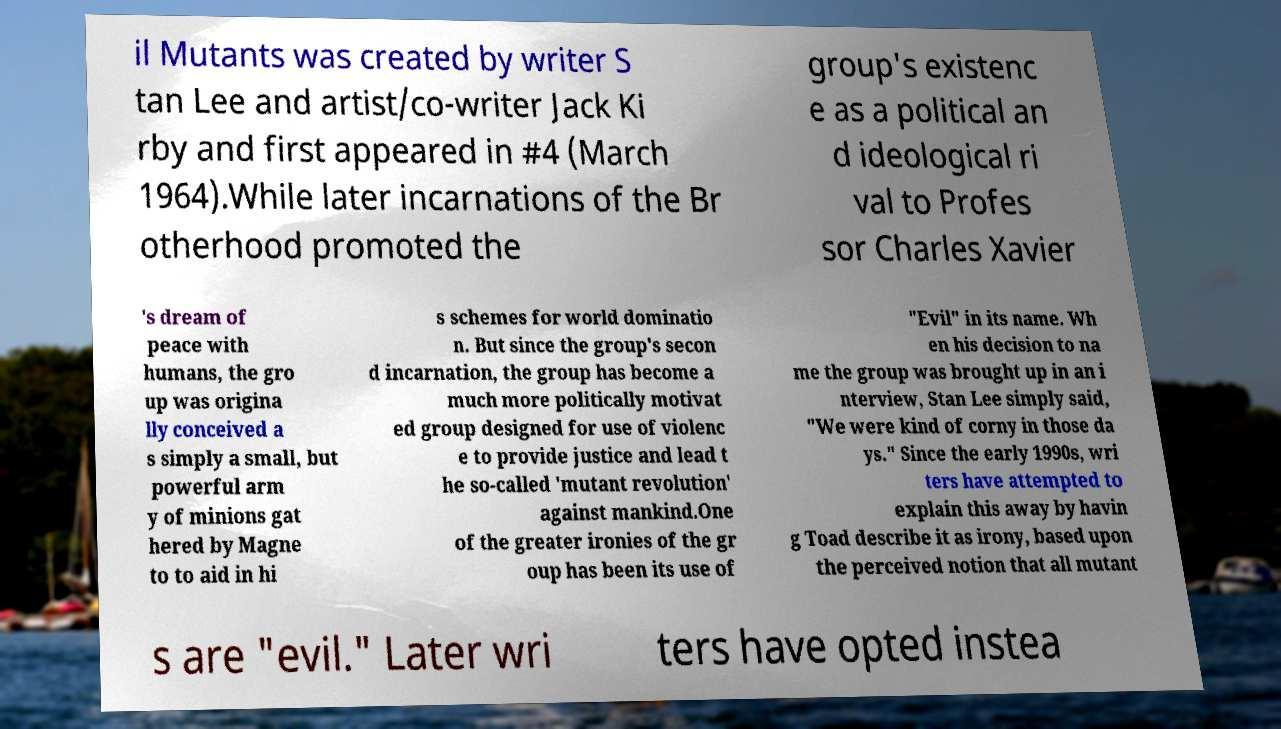Please read and relay the text visible in this image. What does it say? il Mutants was created by writer S tan Lee and artist/co-writer Jack Ki rby and first appeared in #4 (March 1964).While later incarnations of the Br otherhood promoted the group's existenc e as a political an d ideological ri val to Profes sor Charles Xavier 's dream of peace with humans, the gro up was origina lly conceived a s simply a small, but powerful arm y of minions gat hered by Magne to to aid in hi s schemes for world dominatio n. But since the group's secon d incarnation, the group has become a much more politically motivat ed group designed for use of violenc e to provide justice and lead t he so-called 'mutant revolution' against mankind.One of the greater ironies of the gr oup has been its use of "Evil" in its name. Wh en his decision to na me the group was brought up in an i nterview, Stan Lee simply said, "We were kind of corny in those da ys." Since the early 1990s, wri ters have attempted to explain this away by havin g Toad describe it as irony, based upon the perceived notion that all mutant s are "evil." Later wri ters have opted instea 